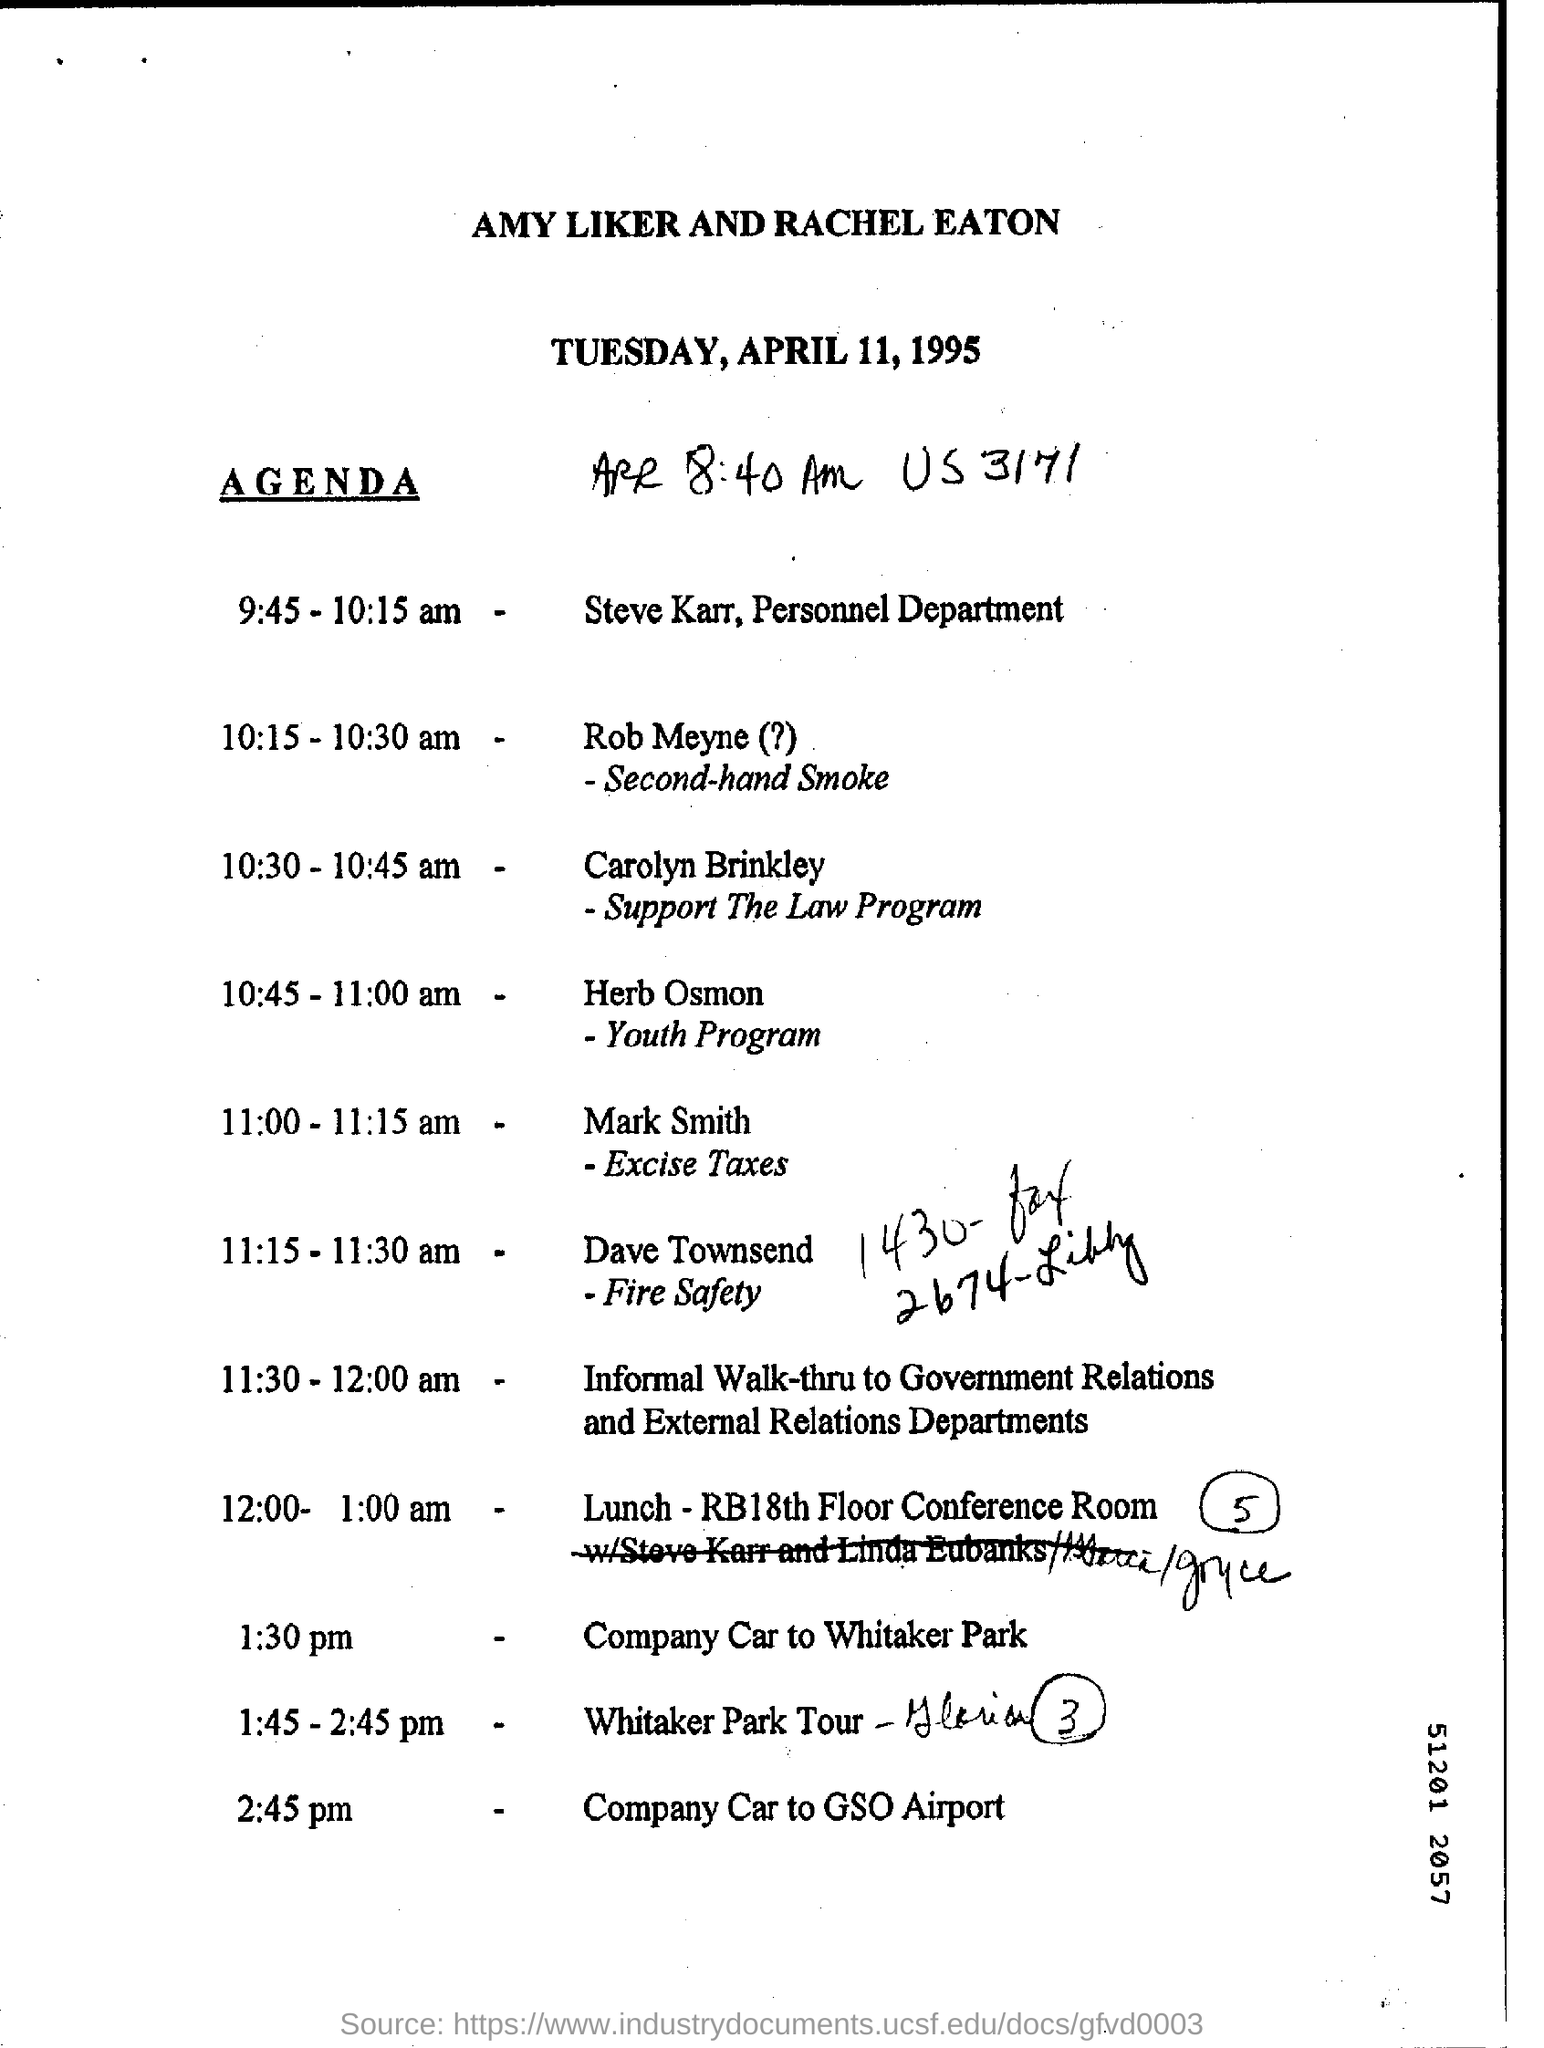What is the day mentioned in the header?
Offer a terse response. TUESDAY. Who handles the Support The Law Program?
Offer a terse response. Carolyn Brinkley. What is the time scheduled for Rob Meyne?
Provide a succinct answer. 10:15 - 10:30 am. Which topic is handled by Dave Townsend?
Your response must be concise. Fire Safety. Steve Karr belongs to which department?
Your response must be concise. Personnel. Where is the lunch arranged as per the agenda?
Offer a terse response. RB18th Floor Conference Room. 